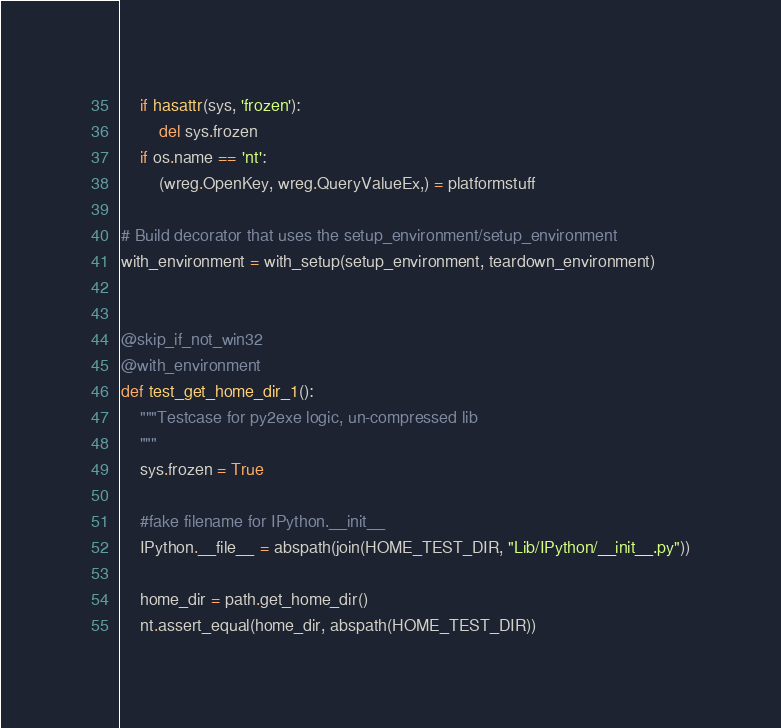<code> <loc_0><loc_0><loc_500><loc_500><_Python_>    if hasattr(sys, 'frozen'):
        del sys.frozen
    if os.name == 'nt':
        (wreg.OpenKey, wreg.QueryValueEx,) = platformstuff

# Build decorator that uses the setup_environment/setup_environment
with_environment = with_setup(setup_environment, teardown_environment)


@skip_if_not_win32
@with_environment
def test_get_home_dir_1():
    """Testcase for py2exe logic, un-compressed lib
    """
    sys.frozen = True
    
    #fake filename for IPython.__init__
    IPython.__file__ = abspath(join(HOME_TEST_DIR, "Lib/IPython/__init__.py"))
    
    home_dir = path.get_home_dir()
    nt.assert_equal(home_dir, abspath(HOME_TEST_DIR))

</code> 